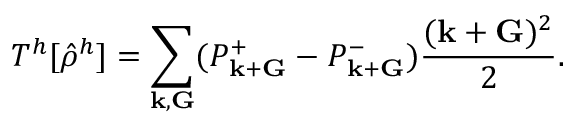Convert formula to latex. <formula><loc_0><loc_0><loc_500><loc_500>T ^ { h } [ \hat { \rho } ^ { h } ] = \sum _ { { k } , { G } } ( P _ { { k } + { G } } ^ { + } - P _ { { k } + { G } } ^ { - } ) \frac { ( { k } + { G } ) ^ { 2 } } { 2 } .</formula> 